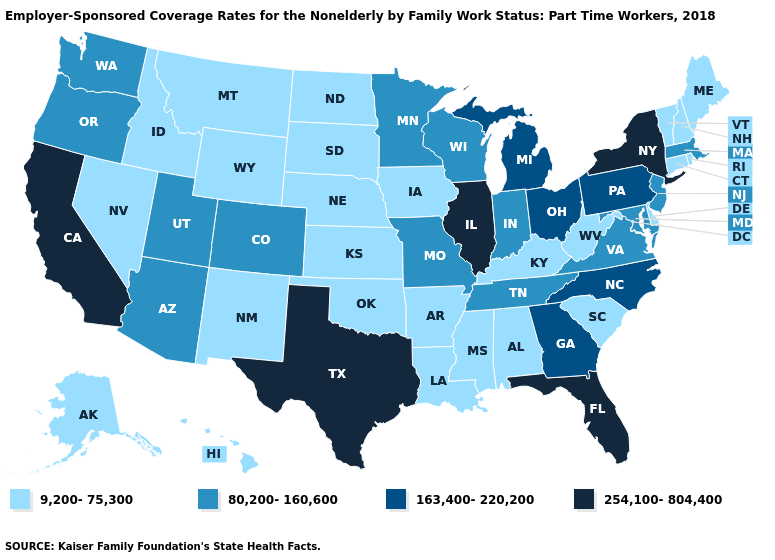What is the value of Oregon?
Quick response, please. 80,200-160,600. What is the value of Missouri?
Short answer required. 80,200-160,600. What is the value of Florida?
Give a very brief answer. 254,100-804,400. What is the value of Iowa?
Give a very brief answer. 9,200-75,300. Which states have the lowest value in the USA?
Keep it brief. Alabama, Alaska, Arkansas, Connecticut, Delaware, Hawaii, Idaho, Iowa, Kansas, Kentucky, Louisiana, Maine, Mississippi, Montana, Nebraska, Nevada, New Hampshire, New Mexico, North Dakota, Oklahoma, Rhode Island, South Carolina, South Dakota, Vermont, West Virginia, Wyoming. What is the lowest value in the Northeast?
Write a very short answer. 9,200-75,300. Does the first symbol in the legend represent the smallest category?
Be succinct. Yes. What is the value of Minnesota?
Keep it brief. 80,200-160,600. Does the map have missing data?
Quick response, please. No. Which states hav the highest value in the West?
Be succinct. California. What is the value of Iowa?
Be succinct. 9,200-75,300. Does Illinois have the highest value in the MidWest?
Keep it brief. Yes. What is the value of Virginia?
Give a very brief answer. 80,200-160,600. Among the states that border Indiana , which have the highest value?
Concise answer only. Illinois. 